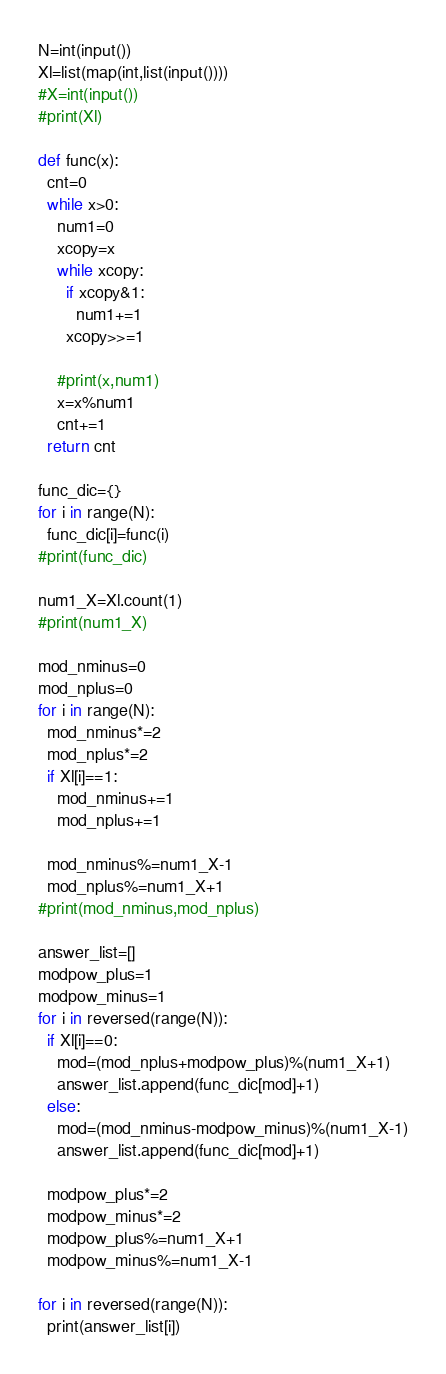<code> <loc_0><loc_0><loc_500><loc_500><_Python_>N=int(input())
Xl=list(map(int,list(input())))
#X=int(input())
#print(Xl)

def func(x):
  cnt=0
  while x>0:
    num1=0
    xcopy=x
    while xcopy:
      if xcopy&1:
        num1+=1
      xcopy>>=1
      
    #print(x,num1)
    x=x%num1
    cnt+=1
  return cnt

func_dic={}
for i in range(N):
  func_dic[i]=func(i)
#print(func_dic)

num1_X=Xl.count(1)
#print(num1_X)

mod_nminus=0
mod_nplus=0
for i in range(N):
  mod_nminus*=2
  mod_nplus*=2
  if Xl[i]==1:
    mod_nminus+=1
    mod_nplus+=1

  mod_nminus%=num1_X-1
  mod_nplus%=num1_X+1
#print(mod_nminus,mod_nplus)

answer_list=[]
modpow_plus=1
modpow_minus=1
for i in reversed(range(N)):
  if Xl[i]==0:
    mod=(mod_nplus+modpow_plus)%(num1_X+1)
    answer_list.append(func_dic[mod]+1)
  else:
    mod=(mod_nminus-modpow_minus)%(num1_X-1)
    answer_list.append(func_dic[mod]+1)
  
  modpow_plus*=2
  modpow_minus*=2
  modpow_plus%=num1_X+1
  modpow_minus%=num1_X-1
  
for i in reversed(range(N)):
  print(answer_list[i])</code> 